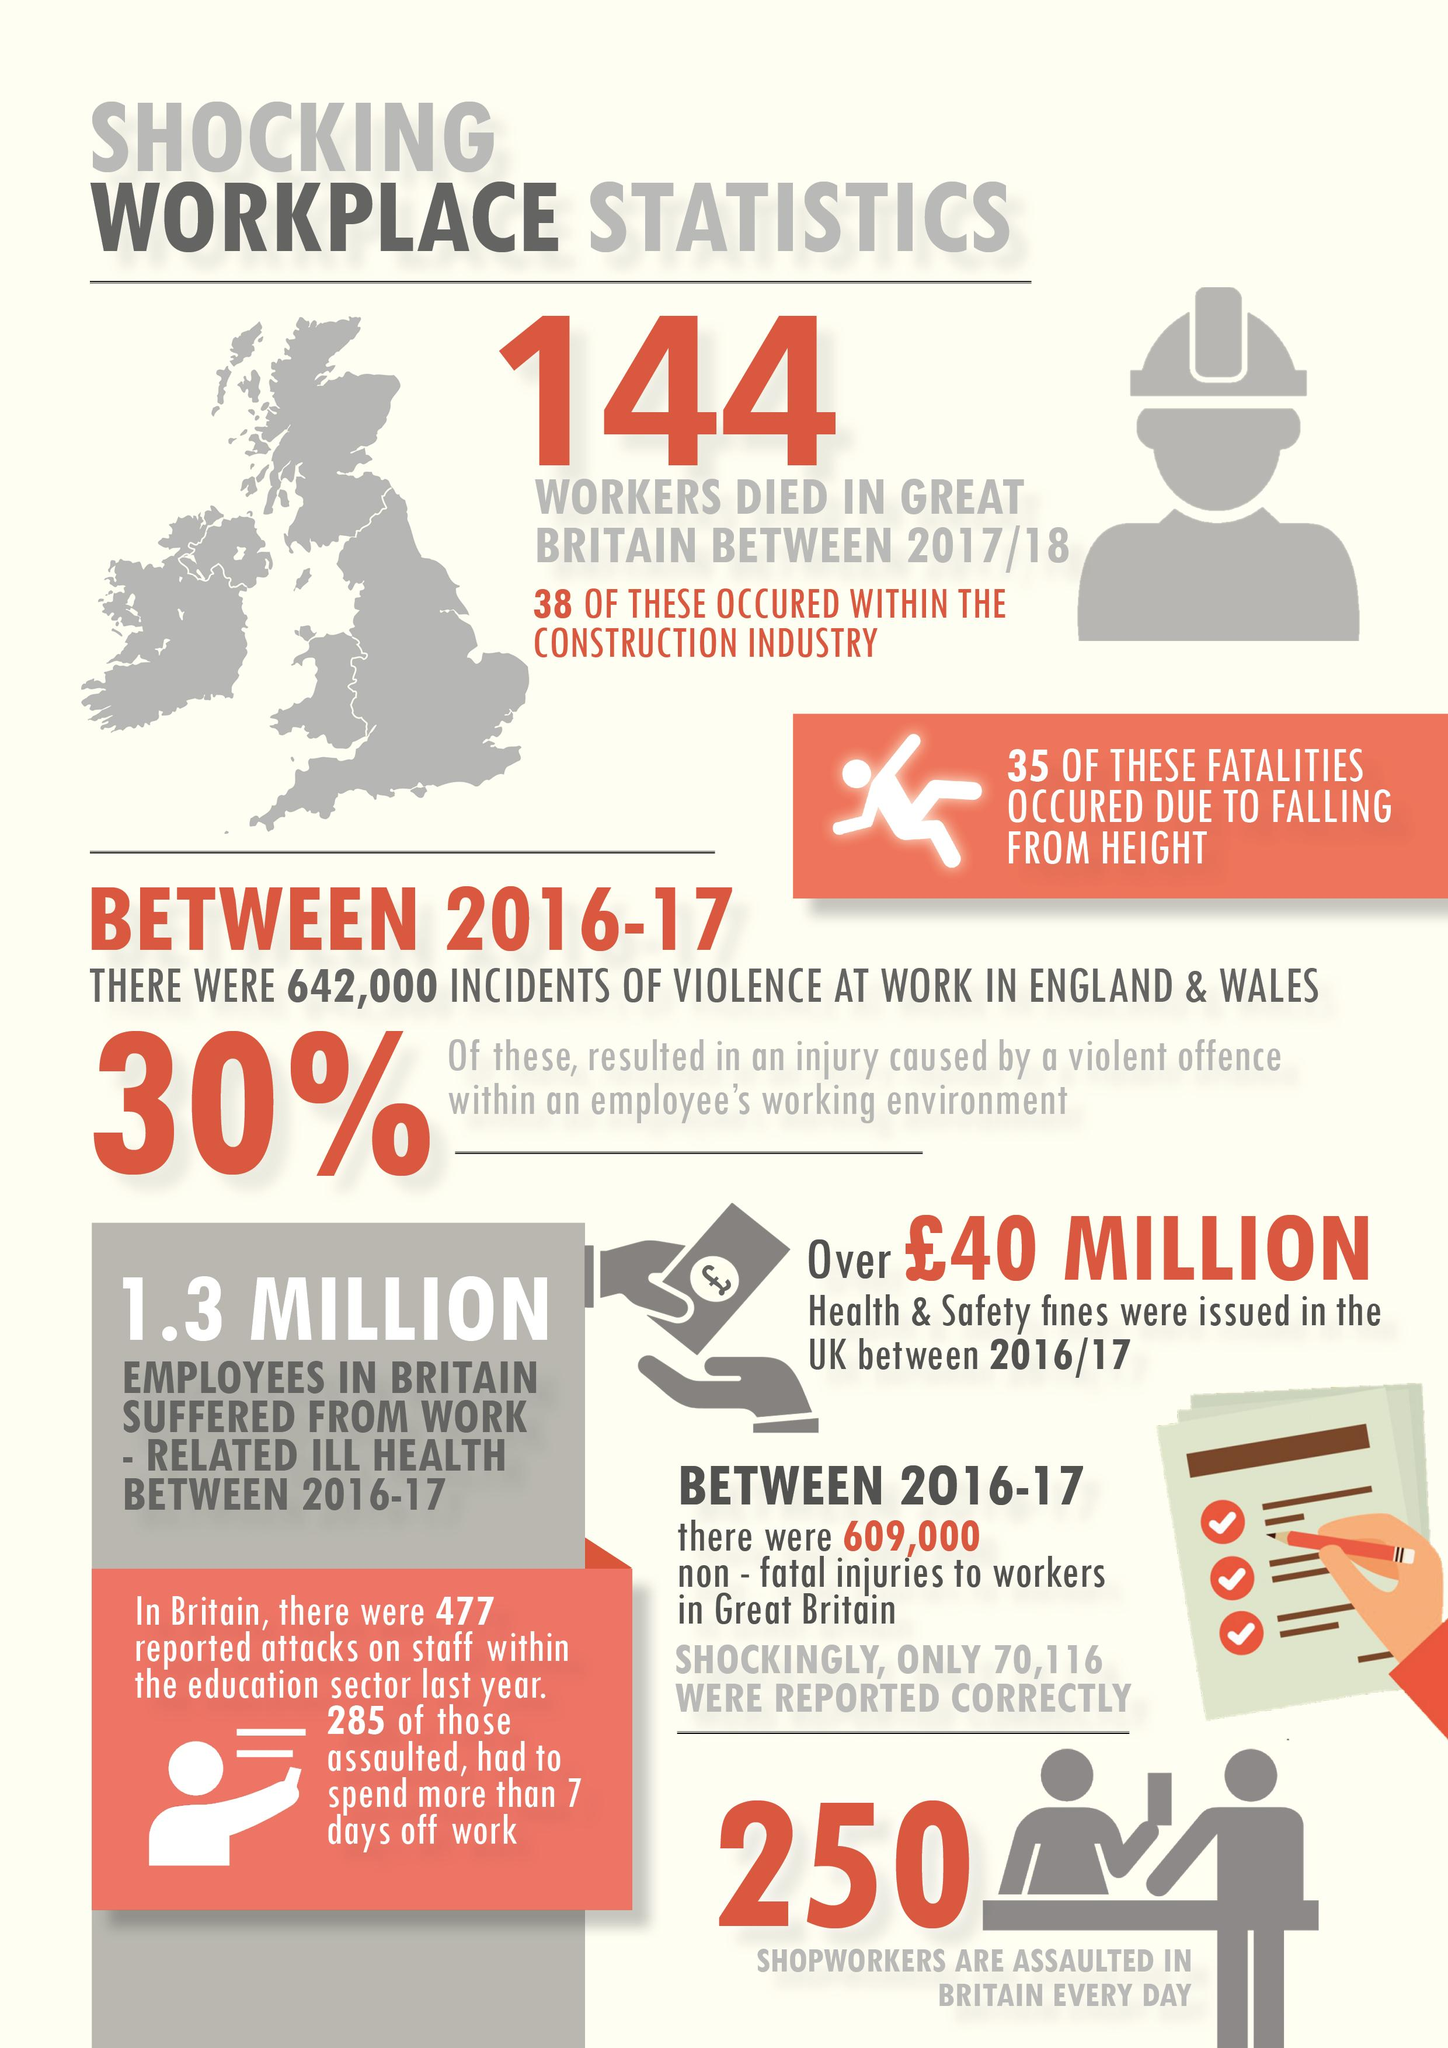Outline some significant characteristics in this image. In Great Britain, according to statistics from the year 2017/18, 26.38% of workers in the construction industry died. 